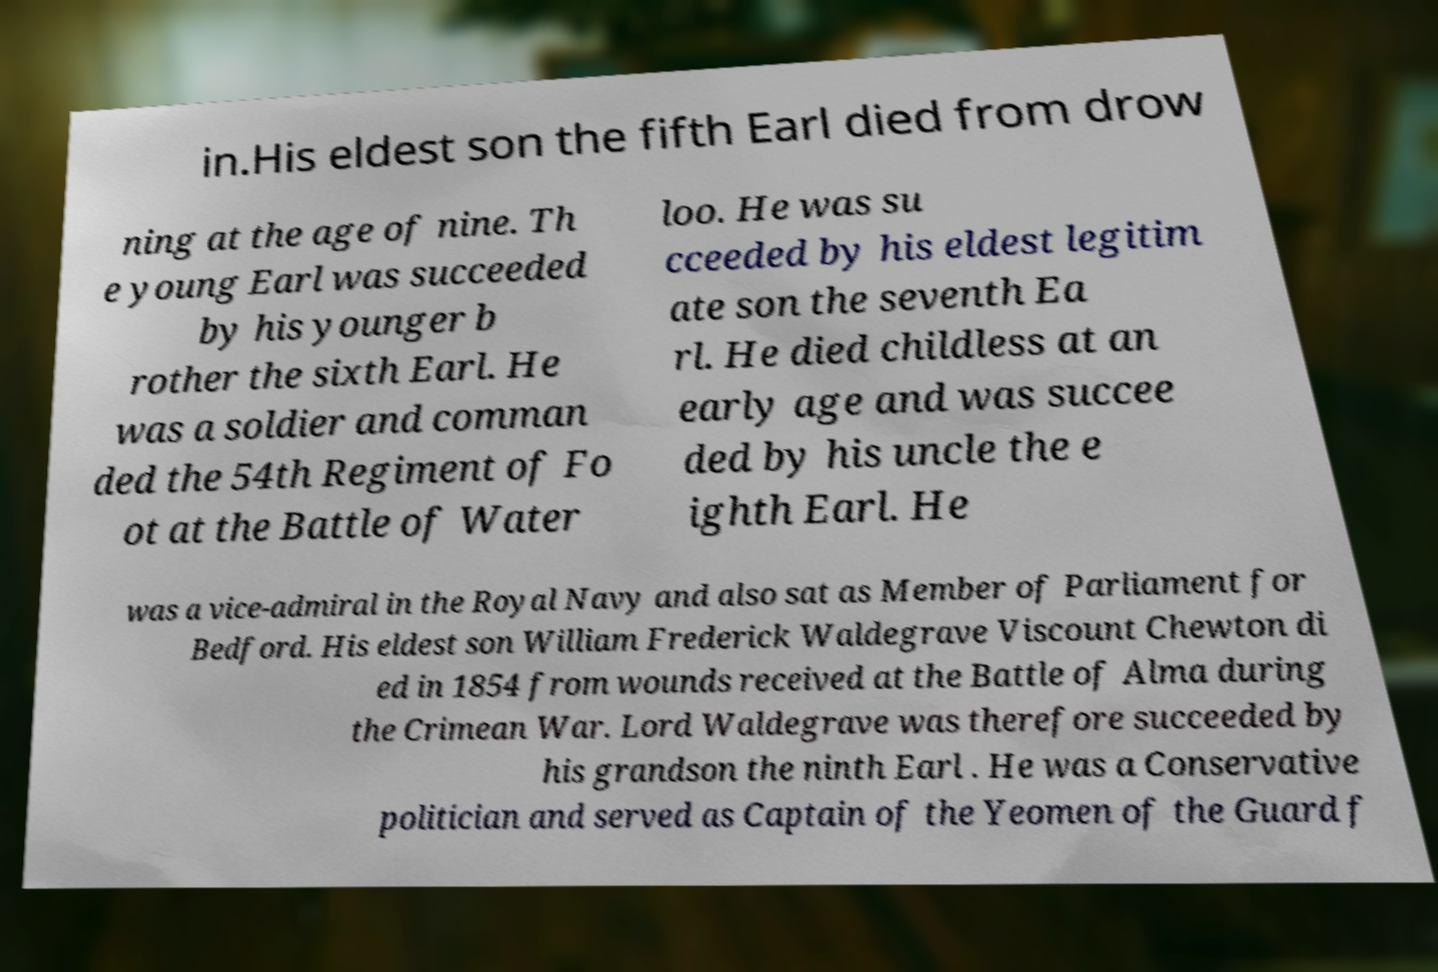For documentation purposes, I need the text within this image transcribed. Could you provide that? in.His eldest son the fifth Earl died from drow ning at the age of nine. Th e young Earl was succeeded by his younger b rother the sixth Earl. He was a soldier and comman ded the 54th Regiment of Fo ot at the Battle of Water loo. He was su cceeded by his eldest legitim ate son the seventh Ea rl. He died childless at an early age and was succee ded by his uncle the e ighth Earl. He was a vice-admiral in the Royal Navy and also sat as Member of Parliament for Bedford. His eldest son William Frederick Waldegrave Viscount Chewton di ed in 1854 from wounds received at the Battle of Alma during the Crimean War. Lord Waldegrave was therefore succeeded by his grandson the ninth Earl . He was a Conservative politician and served as Captain of the Yeomen of the Guard f 